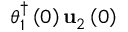Convert formula to latex. <formula><loc_0><loc_0><loc_500><loc_500>\theta _ { 1 } ^ { \dagger } \left ( 0 \right ) u _ { 2 } \left ( 0 \right )</formula> 